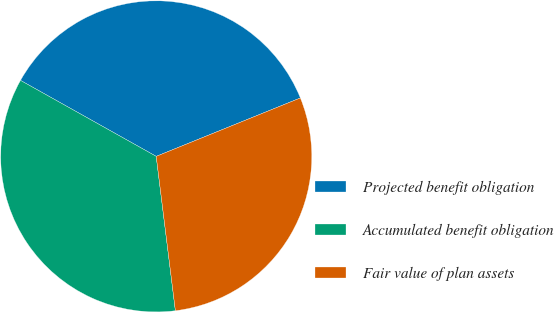Convert chart. <chart><loc_0><loc_0><loc_500><loc_500><pie_chart><fcel>Projected benefit obligation<fcel>Accumulated benefit obligation<fcel>Fair value of plan assets<nl><fcel>35.75%<fcel>35.09%<fcel>29.16%<nl></chart> 